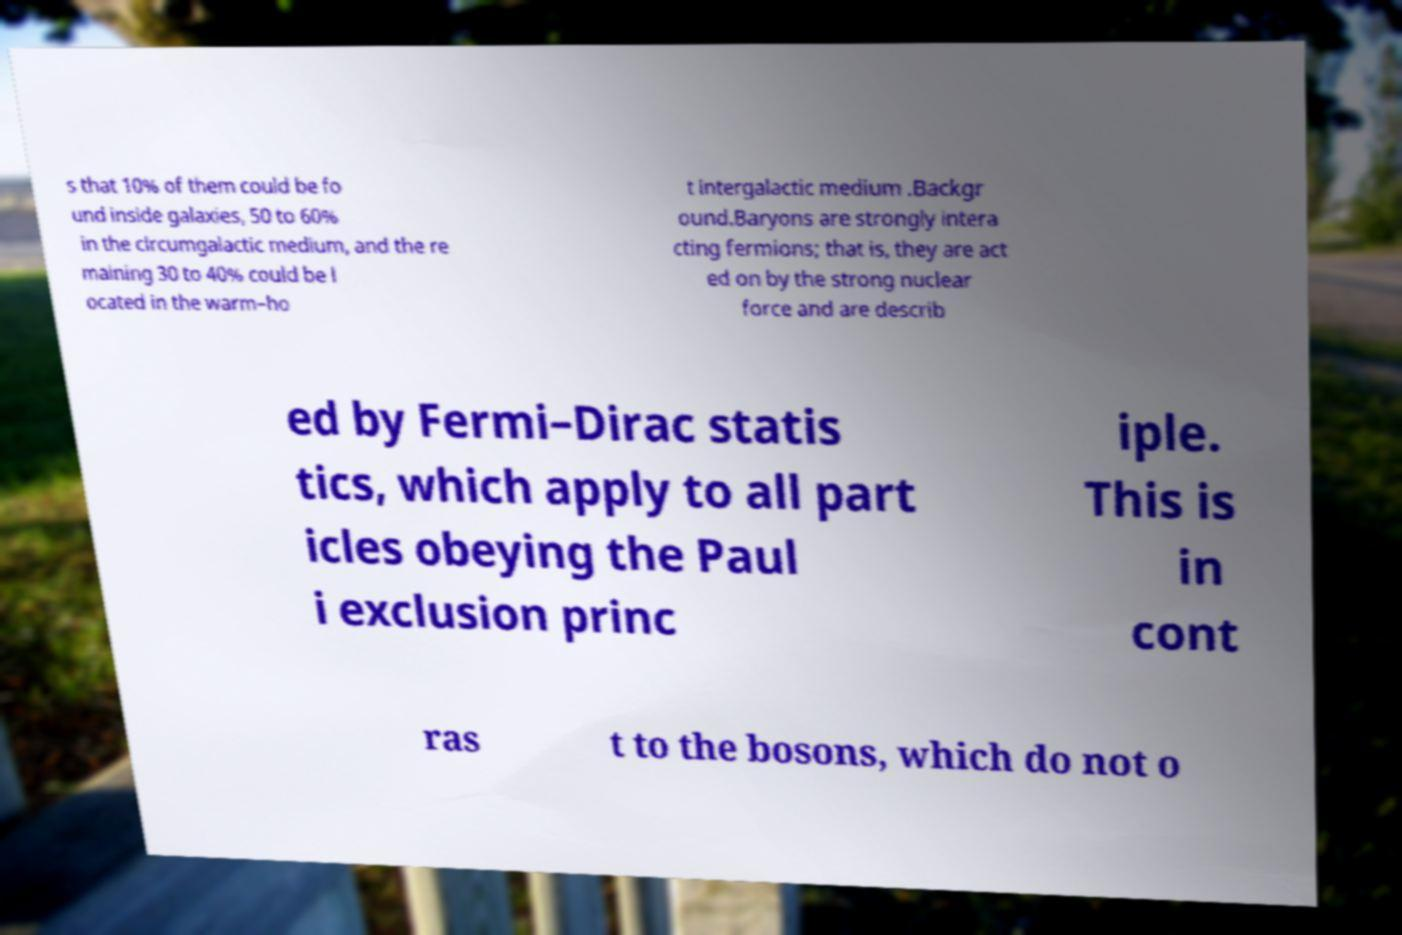What messages or text are displayed in this image? I need them in a readable, typed format. s that 10% of them could be fo und inside galaxies, 50 to 60% in the circumgalactic medium, and the re maining 30 to 40% could be l ocated in the warm–ho t intergalactic medium .Backgr ound.Baryons are strongly intera cting fermions; that is, they are act ed on by the strong nuclear force and are describ ed by Fermi–Dirac statis tics, which apply to all part icles obeying the Paul i exclusion princ iple. This is in cont ras t to the bosons, which do not o 